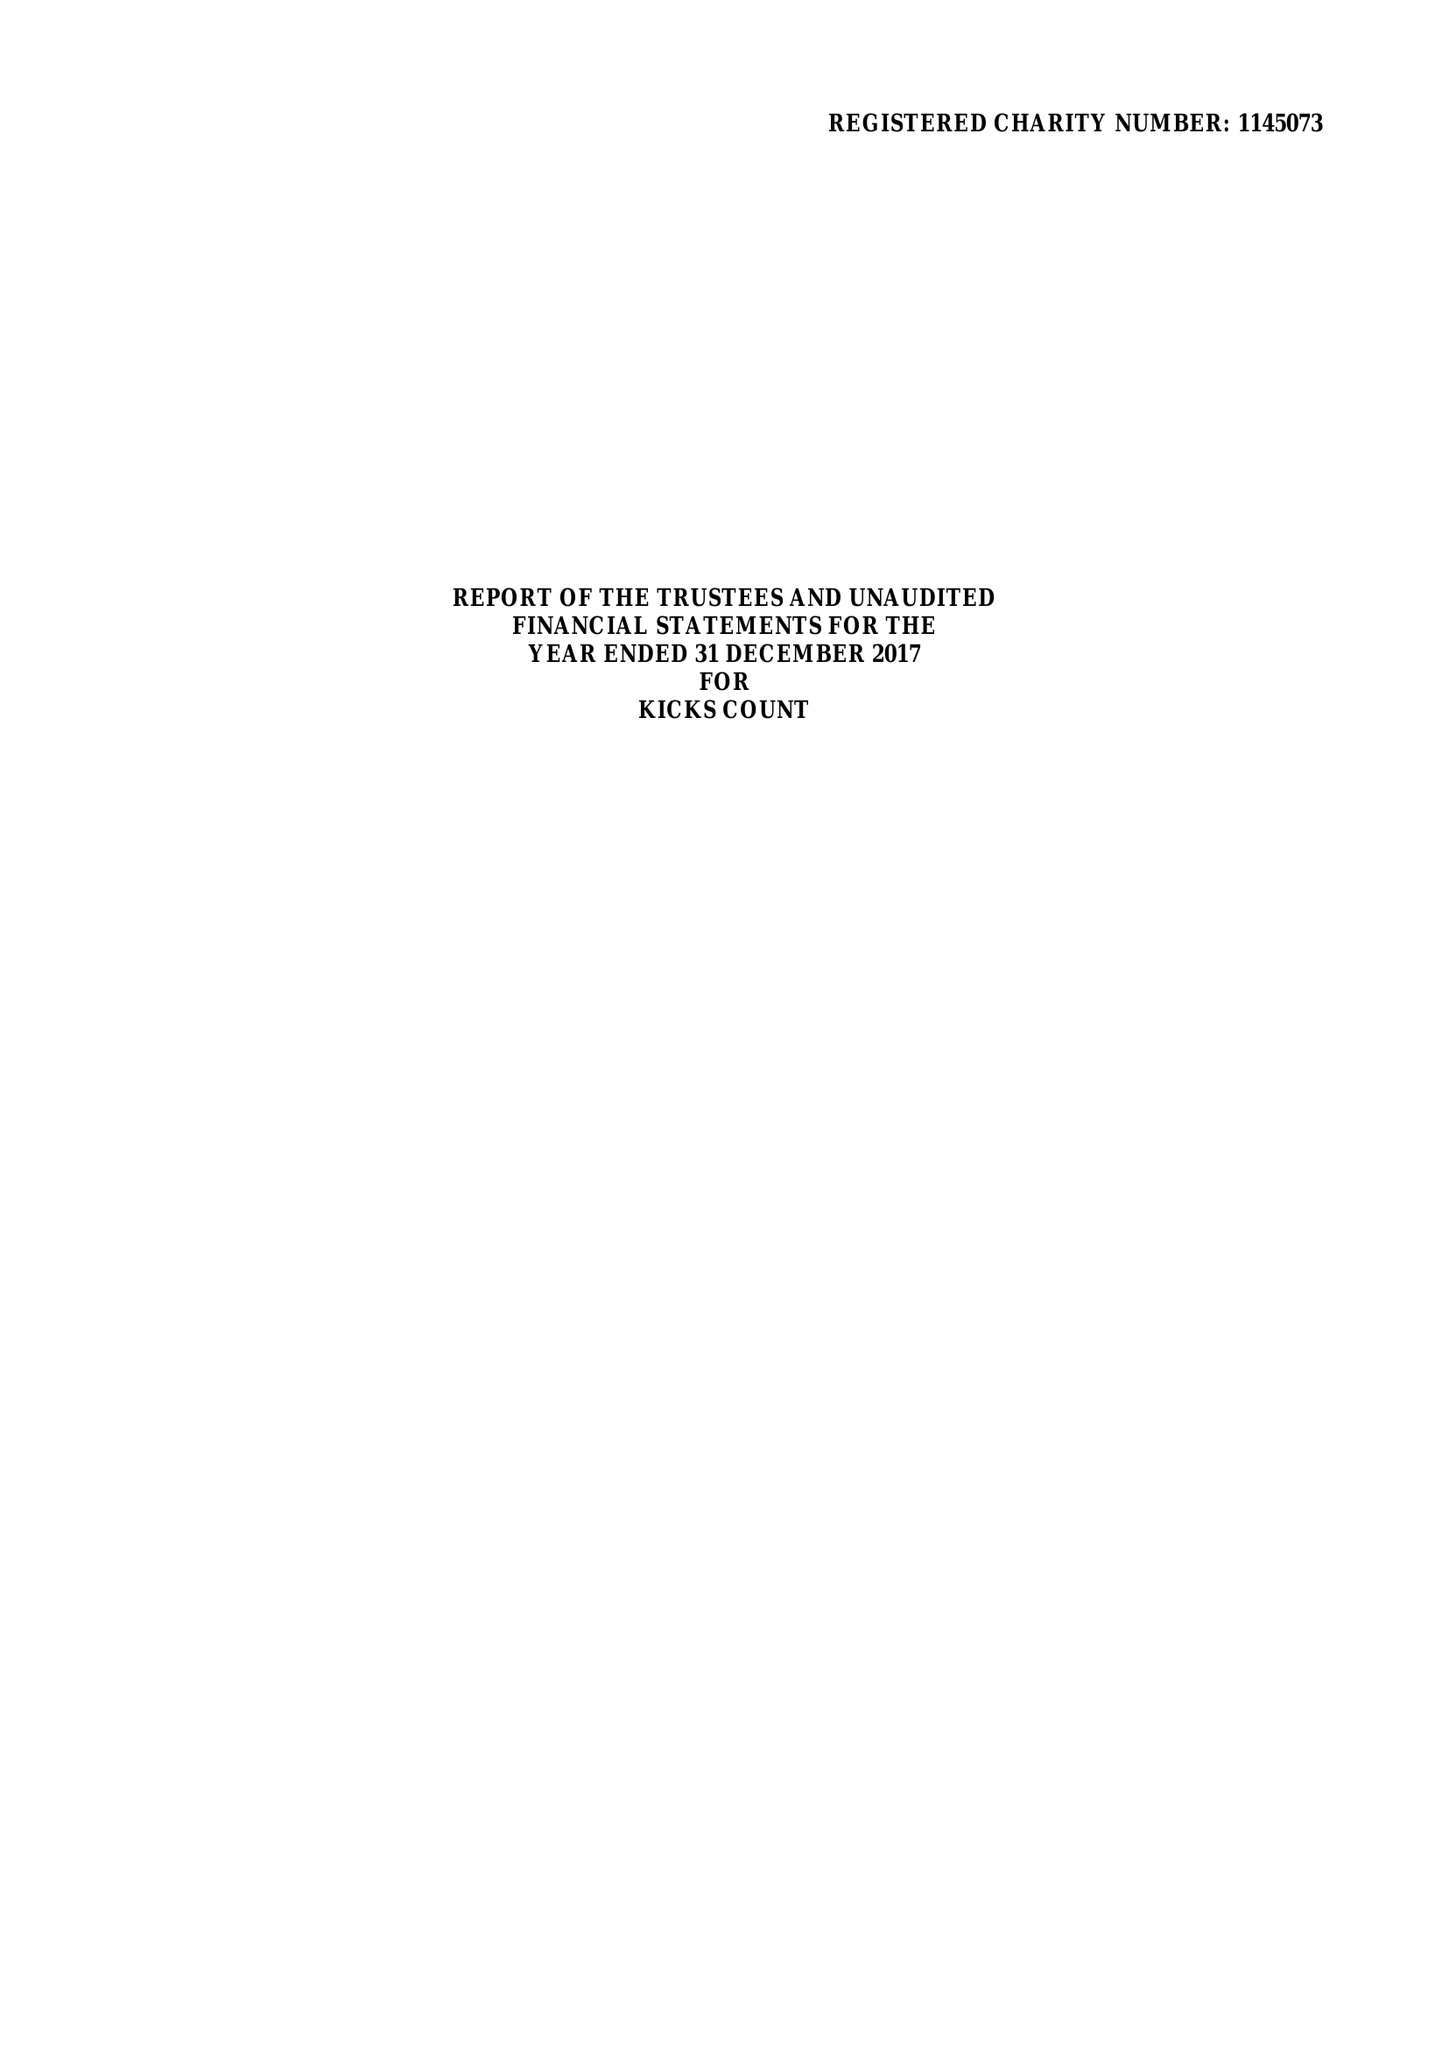What is the value for the spending_annually_in_british_pounds?
Answer the question using a single word or phrase. 189980.00 